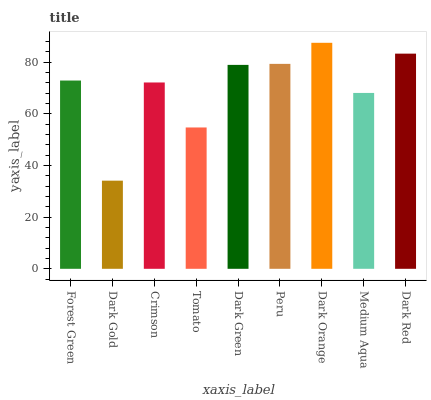Is Dark Gold the minimum?
Answer yes or no. Yes. Is Dark Orange the maximum?
Answer yes or no. Yes. Is Crimson the minimum?
Answer yes or no. No. Is Crimson the maximum?
Answer yes or no. No. Is Crimson greater than Dark Gold?
Answer yes or no. Yes. Is Dark Gold less than Crimson?
Answer yes or no. Yes. Is Dark Gold greater than Crimson?
Answer yes or no. No. Is Crimson less than Dark Gold?
Answer yes or no. No. Is Forest Green the high median?
Answer yes or no. Yes. Is Forest Green the low median?
Answer yes or no. Yes. Is Crimson the high median?
Answer yes or no. No. Is Dark Red the low median?
Answer yes or no. No. 